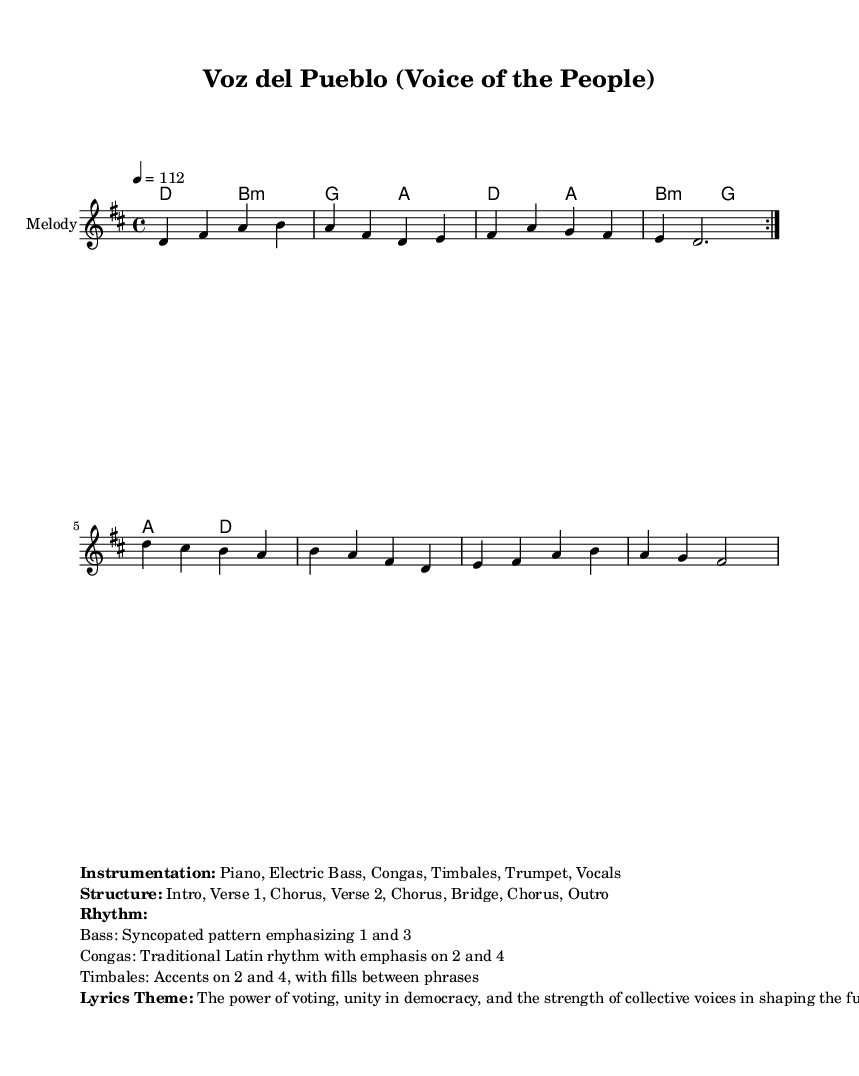What is the key signature of this music? The key signature is indicated at the beginning of the staff and shows two sharps, which corresponds to D major.
Answer: D major What is the time signature of this piece? The time signature is visible at the beginning of the score, showing four beats per measure, which is represented as 4/4.
Answer: 4/4 What is the tempo marking for this music? The tempo marking is found above the staff and indicates the speed of the piece, specified as quarter note equals 112 beats per minute.
Answer: 112 What is the primary theme of the lyrics? The theme can be inferred from the markup section, which describes the lyrics' focus on voting power, democracy, and collective unity.
Answer: The power of voting How many sections are in the structure of the piece? The structure lists eight distinct segments: Intro, Verse 1, Chorus, Verse 2, Chorus, Bridge, Chorus, and Outro, totaling eight sections.
Answer: Eight What instruments are included in the instrumentation? The instrumentation, listed in the markup, comprises piano, electric bass, congas, timbales, trumpet, and vocals.
Answer: Piano, Electric Bass, Congas, Timbales, Trumpet, Vocals How is the rhythm characterized in the bass part? The rhythm for the bass part is described in the markup as a syncopated pattern emphasizing beats one and three.
Answer: Syncopated pattern 